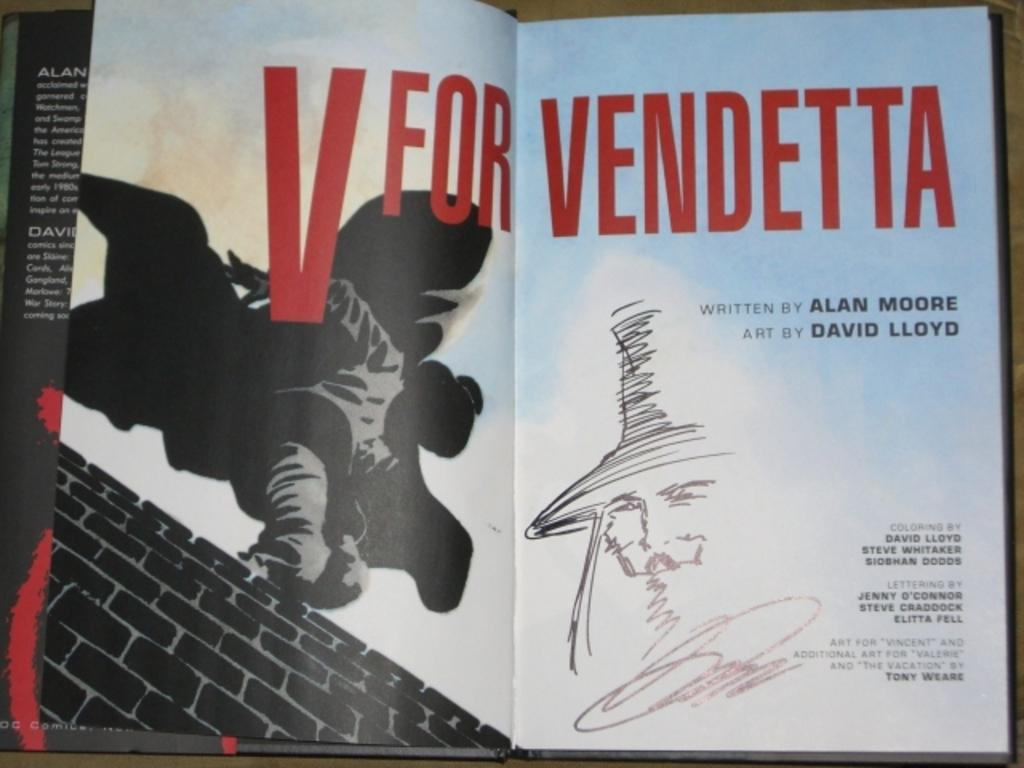<image>
Relay a brief, clear account of the picture shown. A cartoon book with V for Vendetta spread across the pages. 